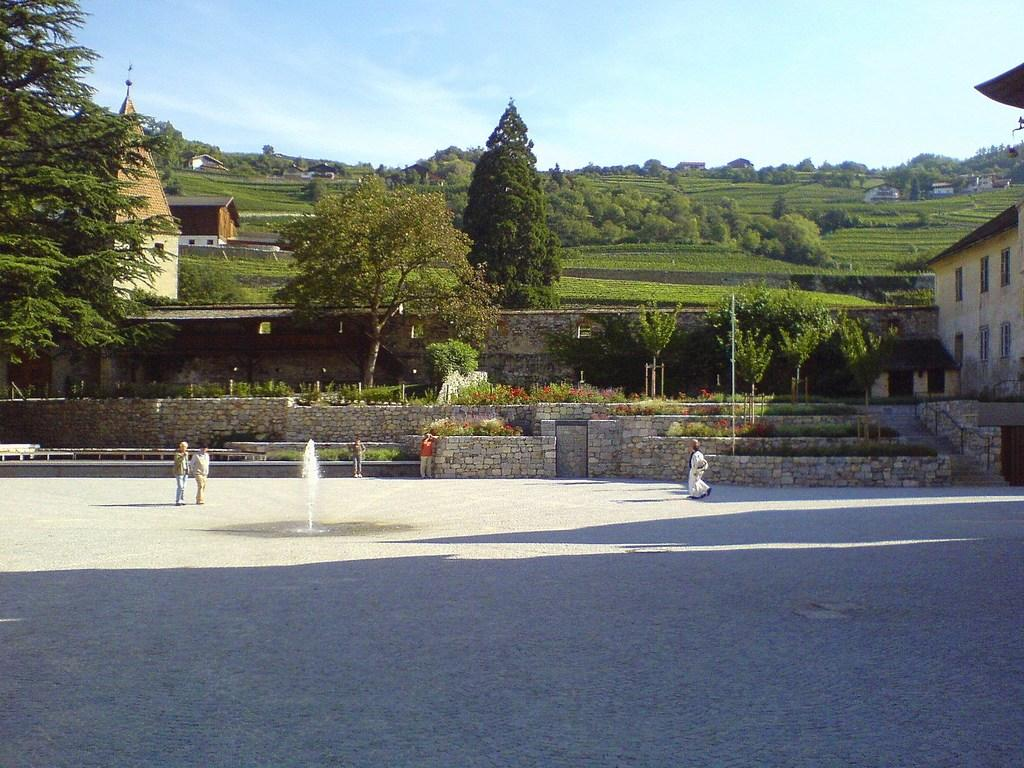How many people are walking on the road in the image? There are three people walking on the road in the image. How many people are standing in the image? There are two people standing in the image. What can be seen in the image besides people? Water, walls, plants, trees, houses with windows, and the sky are visible in the image. Can you describe the houses in the image? The houses in the image have windows. What type of society is depicted in the image? The image does not depict a society; it shows people walking and standing, as well as various environmental elements. Can you provide an example of a front in the image? There is no specific "front" mentioned or depicted in the image; it shows a scene with people, houses, and natural elements. 